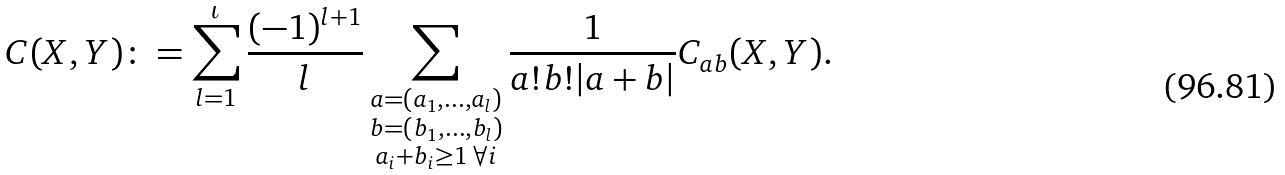<formula> <loc_0><loc_0><loc_500><loc_500>C ( X , Y ) \colon = \sum _ { l = 1 } ^ { \iota } \frac { ( - 1 ) ^ { l + 1 } } { l } \sum _ { \substack { a = ( a _ { 1 } , \dots , a _ { l } ) \\ b = ( b _ { 1 } , \dots , b _ { l } ) \\ a _ { i } + b _ { i } \geq 1 \, \forall i } } \frac { 1 } { a ! b ! | a + b | } C _ { a b } ( X , Y ) .</formula> 